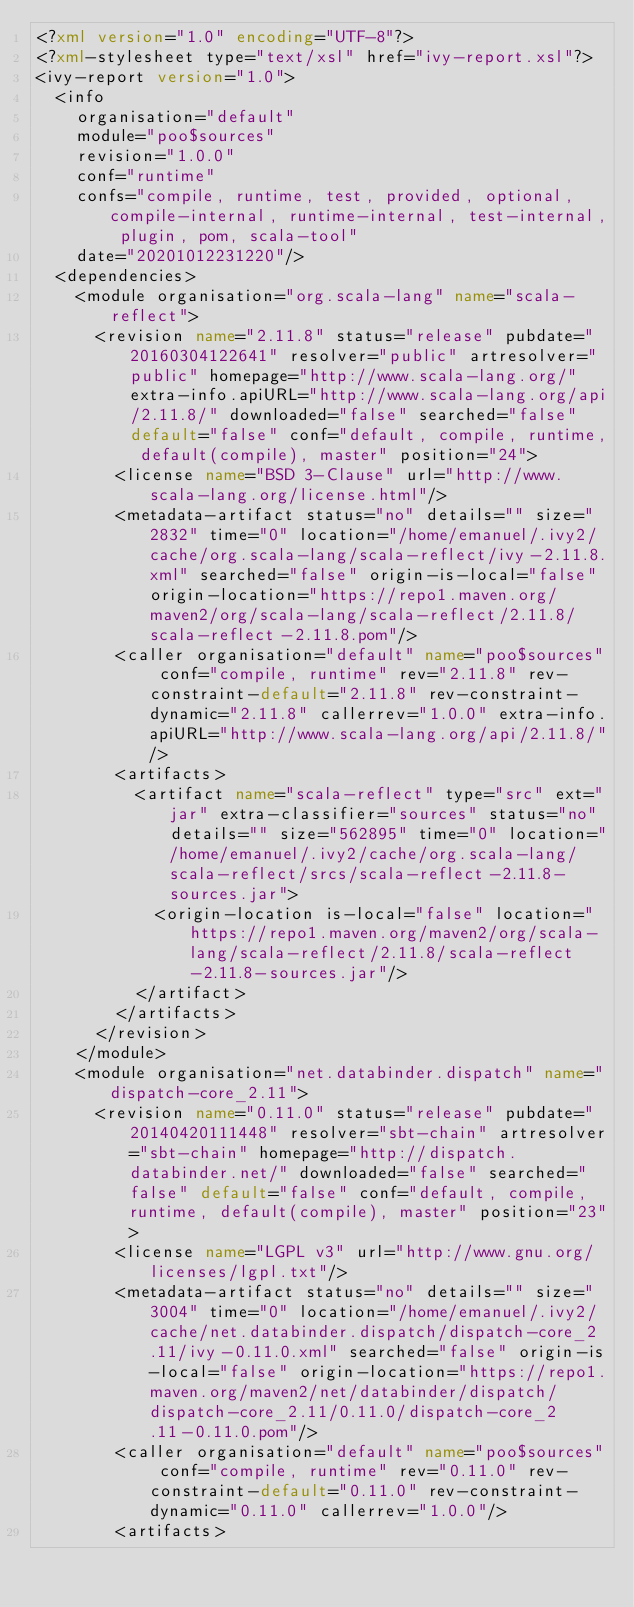<code> <loc_0><loc_0><loc_500><loc_500><_XML_><?xml version="1.0" encoding="UTF-8"?>
<?xml-stylesheet type="text/xsl" href="ivy-report.xsl"?>
<ivy-report version="1.0">
	<info
		organisation="default"
		module="poo$sources"
		revision="1.0.0"
		conf="runtime"
		confs="compile, runtime, test, provided, optional, compile-internal, runtime-internal, test-internal, plugin, pom, scala-tool"
		date="20201012231220"/>
	<dependencies>
		<module organisation="org.scala-lang" name="scala-reflect">
			<revision name="2.11.8" status="release" pubdate="20160304122641" resolver="public" artresolver="public" homepage="http://www.scala-lang.org/" extra-info.apiURL="http://www.scala-lang.org/api/2.11.8/" downloaded="false" searched="false" default="false" conf="default, compile, runtime, default(compile), master" position="24">
				<license name="BSD 3-Clause" url="http://www.scala-lang.org/license.html"/>
				<metadata-artifact status="no" details="" size="2832" time="0" location="/home/emanuel/.ivy2/cache/org.scala-lang/scala-reflect/ivy-2.11.8.xml" searched="false" origin-is-local="false" origin-location="https://repo1.maven.org/maven2/org/scala-lang/scala-reflect/2.11.8/scala-reflect-2.11.8.pom"/>
				<caller organisation="default" name="poo$sources" conf="compile, runtime" rev="2.11.8" rev-constraint-default="2.11.8" rev-constraint-dynamic="2.11.8" callerrev="1.0.0" extra-info.apiURL="http://www.scala-lang.org/api/2.11.8/"/>
				<artifacts>
					<artifact name="scala-reflect" type="src" ext="jar" extra-classifier="sources" status="no" details="" size="562895" time="0" location="/home/emanuel/.ivy2/cache/org.scala-lang/scala-reflect/srcs/scala-reflect-2.11.8-sources.jar">
						<origin-location is-local="false" location="https://repo1.maven.org/maven2/org/scala-lang/scala-reflect/2.11.8/scala-reflect-2.11.8-sources.jar"/>
					</artifact>
				</artifacts>
			</revision>
		</module>
		<module organisation="net.databinder.dispatch" name="dispatch-core_2.11">
			<revision name="0.11.0" status="release" pubdate="20140420111448" resolver="sbt-chain" artresolver="sbt-chain" homepage="http://dispatch.databinder.net/" downloaded="false" searched="false" default="false" conf="default, compile, runtime, default(compile), master" position="23">
				<license name="LGPL v3" url="http://www.gnu.org/licenses/lgpl.txt"/>
				<metadata-artifact status="no" details="" size="3004" time="0" location="/home/emanuel/.ivy2/cache/net.databinder.dispatch/dispatch-core_2.11/ivy-0.11.0.xml" searched="false" origin-is-local="false" origin-location="https://repo1.maven.org/maven2/net/databinder/dispatch/dispatch-core_2.11/0.11.0/dispatch-core_2.11-0.11.0.pom"/>
				<caller organisation="default" name="poo$sources" conf="compile, runtime" rev="0.11.0" rev-constraint-default="0.11.0" rev-constraint-dynamic="0.11.0" callerrev="1.0.0"/>
				<artifacts></code> 